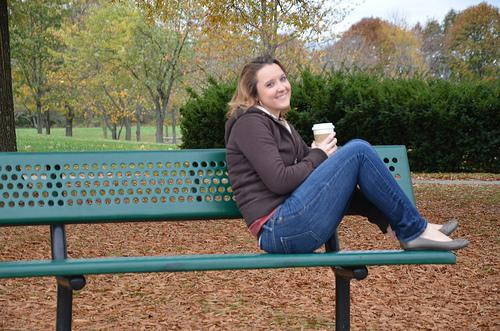Question: where was the photo taken?
Choices:
A. On a bridge.
B. On the park bench.
C. Under a canopy.
D. At a picnic.
Answer with the letter. Answer: B Question: what is the woman sitting on?
Choices:
A. Chair.
B. Curb.
C. Grass.
D. Bench.
Answer with the letter. Answer: D Question: what is the bench made of?
Choices:
A. Wood.
B. Metal.
C. Plastic.
D. Granite.
Answer with the letter. Answer: B Question: what kind of pants is the woman wearing?
Choices:
A. Jeans.
B. Capris.
C. Pallazo.
D. Shorts.
Answer with the letter. Answer: A 